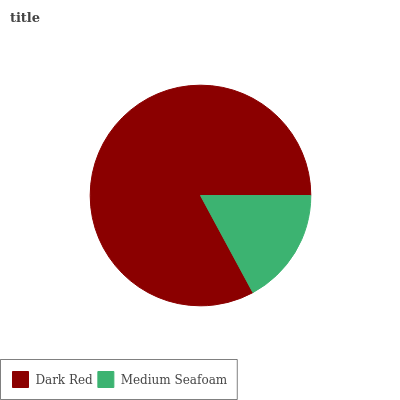Is Medium Seafoam the minimum?
Answer yes or no. Yes. Is Dark Red the maximum?
Answer yes or no. Yes. Is Medium Seafoam the maximum?
Answer yes or no. No. Is Dark Red greater than Medium Seafoam?
Answer yes or no. Yes. Is Medium Seafoam less than Dark Red?
Answer yes or no. Yes. Is Medium Seafoam greater than Dark Red?
Answer yes or no. No. Is Dark Red less than Medium Seafoam?
Answer yes or no. No. Is Dark Red the high median?
Answer yes or no. Yes. Is Medium Seafoam the low median?
Answer yes or no. Yes. Is Medium Seafoam the high median?
Answer yes or no. No. Is Dark Red the low median?
Answer yes or no. No. 